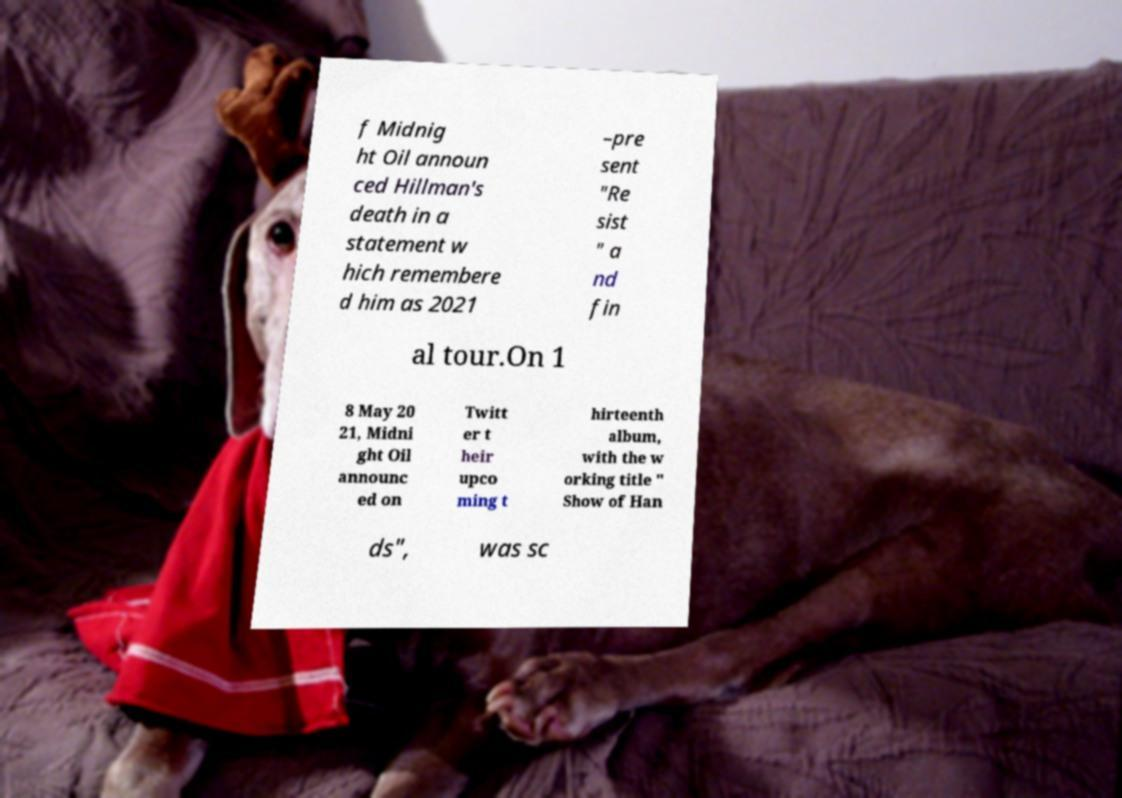Can you accurately transcribe the text from the provided image for me? f Midnig ht Oil announ ced Hillman's death in a statement w hich remembere d him as 2021 –pre sent "Re sist " a nd fin al tour.On 1 8 May 20 21, Midni ght Oil announc ed on Twitt er t heir upco ming t hirteenth album, with the w orking title " Show of Han ds", was sc 